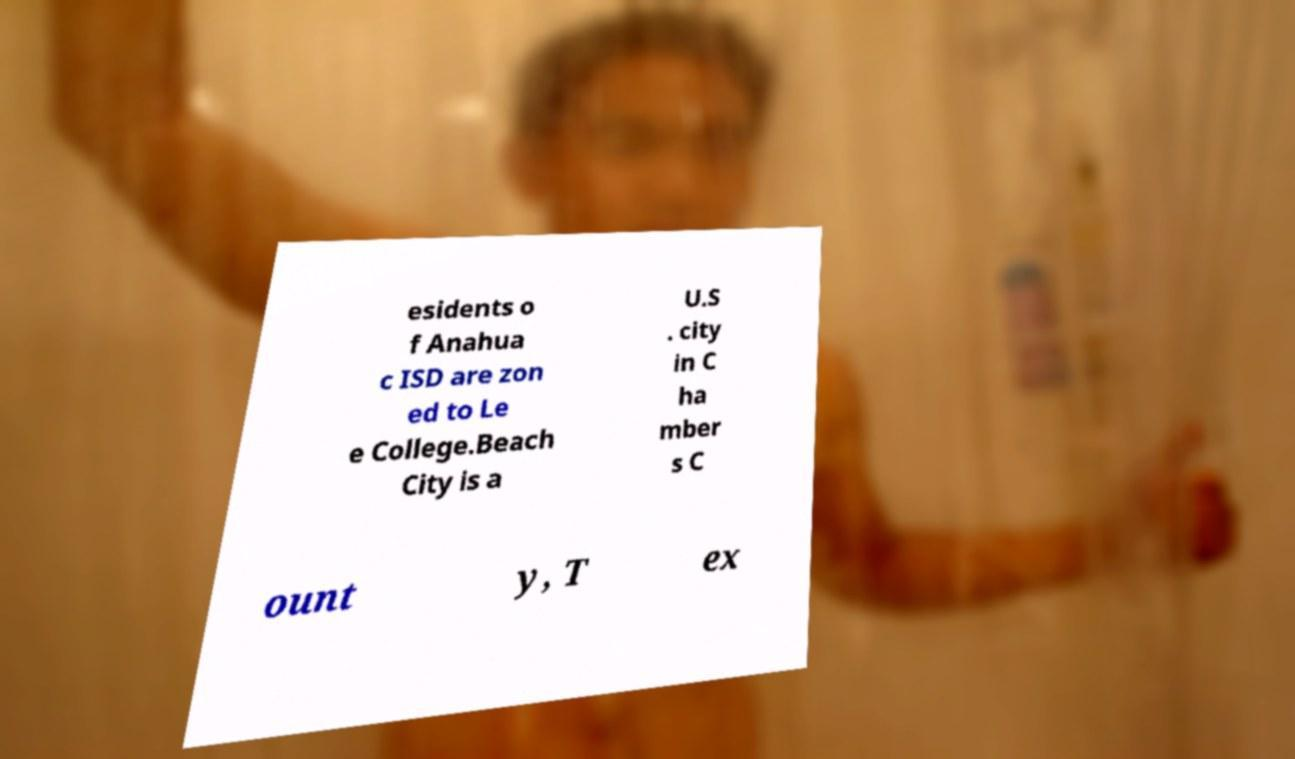What messages or text are displayed in this image? I need them in a readable, typed format. esidents o f Anahua c ISD are zon ed to Le e College.Beach City is a U.S . city in C ha mber s C ount y, T ex 